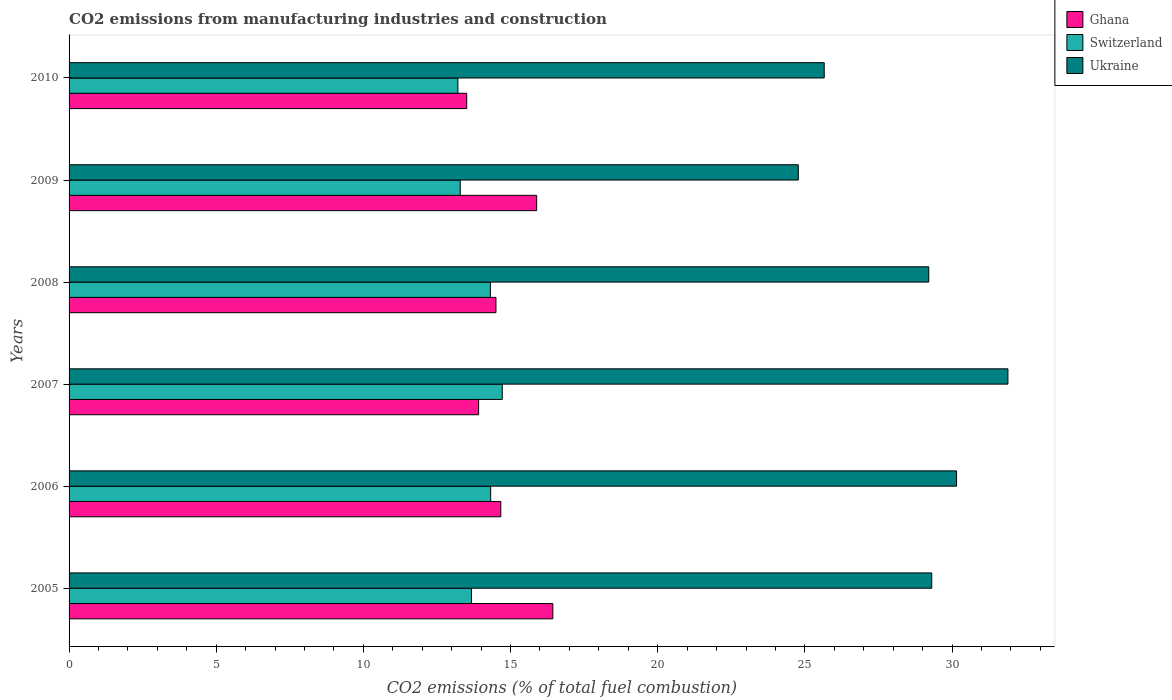How many different coloured bars are there?
Give a very brief answer. 3. How many groups of bars are there?
Provide a short and direct response. 6. Are the number of bars per tick equal to the number of legend labels?
Provide a short and direct response. Yes. Are the number of bars on each tick of the Y-axis equal?
Provide a succinct answer. Yes. What is the amount of CO2 emitted in Ghana in 2007?
Ensure brevity in your answer.  13.92. Across all years, what is the maximum amount of CO2 emitted in Ghana?
Provide a short and direct response. 16.44. Across all years, what is the minimum amount of CO2 emitted in Switzerland?
Offer a terse response. 13.21. In which year was the amount of CO2 emitted in Ukraine maximum?
Your answer should be very brief. 2007. What is the total amount of CO2 emitted in Switzerland in the graph?
Your answer should be compact. 83.53. What is the difference between the amount of CO2 emitted in Switzerland in 2006 and that in 2008?
Ensure brevity in your answer.  0.01. What is the difference between the amount of CO2 emitted in Ghana in 2006 and the amount of CO2 emitted in Ukraine in 2005?
Offer a very short reply. -14.64. What is the average amount of CO2 emitted in Ukraine per year?
Your answer should be compact. 28.5. In the year 2007, what is the difference between the amount of CO2 emitted in Ukraine and amount of CO2 emitted in Ghana?
Give a very brief answer. 17.98. In how many years, is the amount of CO2 emitted in Ghana greater than 20 %?
Your answer should be very brief. 0. What is the ratio of the amount of CO2 emitted in Ghana in 2005 to that in 2010?
Offer a terse response. 1.22. Is the amount of CO2 emitted in Ghana in 2005 less than that in 2008?
Offer a terse response. No. What is the difference between the highest and the second highest amount of CO2 emitted in Switzerland?
Provide a succinct answer. 0.39. What is the difference between the highest and the lowest amount of CO2 emitted in Switzerland?
Provide a short and direct response. 1.51. In how many years, is the amount of CO2 emitted in Ghana greater than the average amount of CO2 emitted in Ghana taken over all years?
Provide a succinct answer. 2. What does the 2nd bar from the top in 2008 represents?
Ensure brevity in your answer.  Switzerland. What does the 3rd bar from the bottom in 2007 represents?
Ensure brevity in your answer.  Ukraine. How many years are there in the graph?
Ensure brevity in your answer.  6. What is the title of the graph?
Give a very brief answer. CO2 emissions from manufacturing industries and construction. What is the label or title of the X-axis?
Keep it short and to the point. CO2 emissions (% of total fuel combustion). What is the CO2 emissions (% of total fuel combustion) of Ghana in 2005?
Provide a short and direct response. 16.44. What is the CO2 emissions (% of total fuel combustion) in Switzerland in 2005?
Offer a very short reply. 13.67. What is the CO2 emissions (% of total fuel combustion) of Ukraine in 2005?
Your answer should be very brief. 29.31. What is the CO2 emissions (% of total fuel combustion) in Ghana in 2006?
Give a very brief answer. 14.67. What is the CO2 emissions (% of total fuel combustion) of Switzerland in 2006?
Offer a terse response. 14.32. What is the CO2 emissions (% of total fuel combustion) of Ukraine in 2006?
Your answer should be very brief. 30.15. What is the CO2 emissions (% of total fuel combustion) of Ghana in 2007?
Your answer should be very brief. 13.92. What is the CO2 emissions (% of total fuel combustion) of Switzerland in 2007?
Provide a short and direct response. 14.72. What is the CO2 emissions (% of total fuel combustion) of Ukraine in 2007?
Your answer should be compact. 31.9. What is the CO2 emissions (% of total fuel combustion) in Ghana in 2008?
Give a very brief answer. 14.5. What is the CO2 emissions (% of total fuel combustion) in Switzerland in 2008?
Your answer should be compact. 14.32. What is the CO2 emissions (% of total fuel combustion) in Ukraine in 2008?
Make the answer very short. 29.21. What is the CO2 emissions (% of total fuel combustion) in Ghana in 2009?
Provide a succinct answer. 15.89. What is the CO2 emissions (% of total fuel combustion) of Switzerland in 2009?
Keep it short and to the point. 13.29. What is the CO2 emissions (% of total fuel combustion) of Ukraine in 2009?
Make the answer very short. 24.78. What is the CO2 emissions (% of total fuel combustion) in Ghana in 2010?
Ensure brevity in your answer.  13.51. What is the CO2 emissions (% of total fuel combustion) of Switzerland in 2010?
Keep it short and to the point. 13.21. What is the CO2 emissions (% of total fuel combustion) of Ukraine in 2010?
Give a very brief answer. 25.66. Across all years, what is the maximum CO2 emissions (% of total fuel combustion) in Ghana?
Make the answer very short. 16.44. Across all years, what is the maximum CO2 emissions (% of total fuel combustion) of Switzerland?
Keep it short and to the point. 14.72. Across all years, what is the maximum CO2 emissions (% of total fuel combustion) in Ukraine?
Keep it short and to the point. 31.9. Across all years, what is the minimum CO2 emissions (% of total fuel combustion) of Ghana?
Keep it short and to the point. 13.51. Across all years, what is the minimum CO2 emissions (% of total fuel combustion) of Switzerland?
Give a very brief answer. 13.21. Across all years, what is the minimum CO2 emissions (% of total fuel combustion) of Ukraine?
Ensure brevity in your answer.  24.78. What is the total CO2 emissions (% of total fuel combustion) of Ghana in the graph?
Your answer should be compact. 88.92. What is the total CO2 emissions (% of total fuel combustion) in Switzerland in the graph?
Give a very brief answer. 83.53. What is the total CO2 emissions (% of total fuel combustion) in Ukraine in the graph?
Your response must be concise. 171.01. What is the difference between the CO2 emissions (% of total fuel combustion) in Ghana in 2005 and that in 2006?
Make the answer very short. 1.77. What is the difference between the CO2 emissions (% of total fuel combustion) in Switzerland in 2005 and that in 2006?
Keep it short and to the point. -0.65. What is the difference between the CO2 emissions (% of total fuel combustion) in Ukraine in 2005 and that in 2006?
Your response must be concise. -0.84. What is the difference between the CO2 emissions (% of total fuel combustion) in Ghana in 2005 and that in 2007?
Your answer should be compact. 2.52. What is the difference between the CO2 emissions (% of total fuel combustion) of Switzerland in 2005 and that in 2007?
Provide a succinct answer. -1.05. What is the difference between the CO2 emissions (% of total fuel combustion) in Ukraine in 2005 and that in 2007?
Your response must be concise. -2.59. What is the difference between the CO2 emissions (% of total fuel combustion) in Ghana in 2005 and that in 2008?
Offer a very short reply. 1.93. What is the difference between the CO2 emissions (% of total fuel combustion) in Switzerland in 2005 and that in 2008?
Make the answer very short. -0.64. What is the difference between the CO2 emissions (% of total fuel combustion) of Ukraine in 2005 and that in 2008?
Offer a very short reply. 0.1. What is the difference between the CO2 emissions (% of total fuel combustion) in Ghana in 2005 and that in 2009?
Keep it short and to the point. 0.55. What is the difference between the CO2 emissions (% of total fuel combustion) in Switzerland in 2005 and that in 2009?
Offer a terse response. 0.38. What is the difference between the CO2 emissions (% of total fuel combustion) in Ukraine in 2005 and that in 2009?
Your answer should be very brief. 4.53. What is the difference between the CO2 emissions (% of total fuel combustion) in Ghana in 2005 and that in 2010?
Ensure brevity in your answer.  2.93. What is the difference between the CO2 emissions (% of total fuel combustion) of Switzerland in 2005 and that in 2010?
Provide a succinct answer. 0.46. What is the difference between the CO2 emissions (% of total fuel combustion) of Ukraine in 2005 and that in 2010?
Your response must be concise. 3.65. What is the difference between the CO2 emissions (% of total fuel combustion) in Ghana in 2006 and that in 2007?
Keep it short and to the point. 0.75. What is the difference between the CO2 emissions (% of total fuel combustion) of Switzerland in 2006 and that in 2007?
Ensure brevity in your answer.  -0.39. What is the difference between the CO2 emissions (% of total fuel combustion) of Ukraine in 2006 and that in 2007?
Provide a succinct answer. -1.75. What is the difference between the CO2 emissions (% of total fuel combustion) of Ghana in 2006 and that in 2008?
Your answer should be compact. 0.16. What is the difference between the CO2 emissions (% of total fuel combustion) of Switzerland in 2006 and that in 2008?
Your answer should be very brief. 0.01. What is the difference between the CO2 emissions (% of total fuel combustion) in Ukraine in 2006 and that in 2008?
Your answer should be compact. 0.94. What is the difference between the CO2 emissions (% of total fuel combustion) of Ghana in 2006 and that in 2009?
Make the answer very short. -1.22. What is the difference between the CO2 emissions (% of total fuel combustion) of Switzerland in 2006 and that in 2009?
Offer a terse response. 1.03. What is the difference between the CO2 emissions (% of total fuel combustion) of Ukraine in 2006 and that in 2009?
Keep it short and to the point. 5.38. What is the difference between the CO2 emissions (% of total fuel combustion) of Ghana in 2006 and that in 2010?
Make the answer very short. 1.16. What is the difference between the CO2 emissions (% of total fuel combustion) in Switzerland in 2006 and that in 2010?
Your answer should be very brief. 1.11. What is the difference between the CO2 emissions (% of total fuel combustion) in Ukraine in 2006 and that in 2010?
Give a very brief answer. 4.5. What is the difference between the CO2 emissions (% of total fuel combustion) of Ghana in 2007 and that in 2008?
Your answer should be very brief. -0.59. What is the difference between the CO2 emissions (% of total fuel combustion) in Switzerland in 2007 and that in 2008?
Offer a very short reply. 0.4. What is the difference between the CO2 emissions (% of total fuel combustion) of Ukraine in 2007 and that in 2008?
Provide a succinct answer. 2.69. What is the difference between the CO2 emissions (% of total fuel combustion) in Ghana in 2007 and that in 2009?
Offer a terse response. -1.97. What is the difference between the CO2 emissions (% of total fuel combustion) in Switzerland in 2007 and that in 2009?
Keep it short and to the point. 1.43. What is the difference between the CO2 emissions (% of total fuel combustion) in Ukraine in 2007 and that in 2009?
Provide a succinct answer. 7.12. What is the difference between the CO2 emissions (% of total fuel combustion) of Ghana in 2007 and that in 2010?
Offer a terse response. 0.4. What is the difference between the CO2 emissions (% of total fuel combustion) of Switzerland in 2007 and that in 2010?
Your response must be concise. 1.51. What is the difference between the CO2 emissions (% of total fuel combustion) in Ukraine in 2007 and that in 2010?
Offer a terse response. 6.24. What is the difference between the CO2 emissions (% of total fuel combustion) in Ghana in 2008 and that in 2009?
Offer a terse response. -1.38. What is the difference between the CO2 emissions (% of total fuel combustion) of Switzerland in 2008 and that in 2009?
Your answer should be compact. 1.02. What is the difference between the CO2 emissions (% of total fuel combustion) in Ukraine in 2008 and that in 2009?
Offer a very short reply. 4.43. What is the difference between the CO2 emissions (% of total fuel combustion) in Switzerland in 2008 and that in 2010?
Offer a terse response. 1.1. What is the difference between the CO2 emissions (% of total fuel combustion) of Ukraine in 2008 and that in 2010?
Ensure brevity in your answer.  3.55. What is the difference between the CO2 emissions (% of total fuel combustion) in Ghana in 2009 and that in 2010?
Your answer should be very brief. 2.38. What is the difference between the CO2 emissions (% of total fuel combustion) of Switzerland in 2009 and that in 2010?
Offer a terse response. 0.08. What is the difference between the CO2 emissions (% of total fuel combustion) of Ukraine in 2009 and that in 2010?
Your answer should be compact. -0.88. What is the difference between the CO2 emissions (% of total fuel combustion) of Ghana in 2005 and the CO2 emissions (% of total fuel combustion) of Switzerland in 2006?
Keep it short and to the point. 2.11. What is the difference between the CO2 emissions (% of total fuel combustion) of Ghana in 2005 and the CO2 emissions (% of total fuel combustion) of Ukraine in 2006?
Your response must be concise. -13.72. What is the difference between the CO2 emissions (% of total fuel combustion) in Switzerland in 2005 and the CO2 emissions (% of total fuel combustion) in Ukraine in 2006?
Make the answer very short. -16.48. What is the difference between the CO2 emissions (% of total fuel combustion) in Ghana in 2005 and the CO2 emissions (% of total fuel combustion) in Switzerland in 2007?
Your response must be concise. 1.72. What is the difference between the CO2 emissions (% of total fuel combustion) of Ghana in 2005 and the CO2 emissions (% of total fuel combustion) of Ukraine in 2007?
Your response must be concise. -15.46. What is the difference between the CO2 emissions (% of total fuel combustion) in Switzerland in 2005 and the CO2 emissions (% of total fuel combustion) in Ukraine in 2007?
Give a very brief answer. -18.23. What is the difference between the CO2 emissions (% of total fuel combustion) of Ghana in 2005 and the CO2 emissions (% of total fuel combustion) of Switzerland in 2008?
Your answer should be very brief. 2.12. What is the difference between the CO2 emissions (% of total fuel combustion) in Ghana in 2005 and the CO2 emissions (% of total fuel combustion) in Ukraine in 2008?
Your response must be concise. -12.77. What is the difference between the CO2 emissions (% of total fuel combustion) in Switzerland in 2005 and the CO2 emissions (% of total fuel combustion) in Ukraine in 2008?
Your response must be concise. -15.54. What is the difference between the CO2 emissions (% of total fuel combustion) in Ghana in 2005 and the CO2 emissions (% of total fuel combustion) in Switzerland in 2009?
Keep it short and to the point. 3.15. What is the difference between the CO2 emissions (% of total fuel combustion) of Ghana in 2005 and the CO2 emissions (% of total fuel combustion) of Ukraine in 2009?
Make the answer very short. -8.34. What is the difference between the CO2 emissions (% of total fuel combustion) in Switzerland in 2005 and the CO2 emissions (% of total fuel combustion) in Ukraine in 2009?
Ensure brevity in your answer.  -11.11. What is the difference between the CO2 emissions (% of total fuel combustion) of Ghana in 2005 and the CO2 emissions (% of total fuel combustion) of Switzerland in 2010?
Provide a short and direct response. 3.23. What is the difference between the CO2 emissions (% of total fuel combustion) in Ghana in 2005 and the CO2 emissions (% of total fuel combustion) in Ukraine in 2010?
Your answer should be very brief. -9.22. What is the difference between the CO2 emissions (% of total fuel combustion) in Switzerland in 2005 and the CO2 emissions (% of total fuel combustion) in Ukraine in 2010?
Your answer should be very brief. -11.99. What is the difference between the CO2 emissions (% of total fuel combustion) in Ghana in 2006 and the CO2 emissions (% of total fuel combustion) in Ukraine in 2007?
Your answer should be compact. -17.23. What is the difference between the CO2 emissions (% of total fuel combustion) of Switzerland in 2006 and the CO2 emissions (% of total fuel combustion) of Ukraine in 2007?
Provide a short and direct response. -17.57. What is the difference between the CO2 emissions (% of total fuel combustion) in Ghana in 2006 and the CO2 emissions (% of total fuel combustion) in Switzerland in 2008?
Ensure brevity in your answer.  0.35. What is the difference between the CO2 emissions (% of total fuel combustion) in Ghana in 2006 and the CO2 emissions (% of total fuel combustion) in Ukraine in 2008?
Provide a short and direct response. -14.54. What is the difference between the CO2 emissions (% of total fuel combustion) of Switzerland in 2006 and the CO2 emissions (% of total fuel combustion) of Ukraine in 2008?
Your answer should be very brief. -14.88. What is the difference between the CO2 emissions (% of total fuel combustion) in Ghana in 2006 and the CO2 emissions (% of total fuel combustion) in Switzerland in 2009?
Your answer should be compact. 1.38. What is the difference between the CO2 emissions (% of total fuel combustion) in Ghana in 2006 and the CO2 emissions (% of total fuel combustion) in Ukraine in 2009?
Ensure brevity in your answer.  -10.11. What is the difference between the CO2 emissions (% of total fuel combustion) in Switzerland in 2006 and the CO2 emissions (% of total fuel combustion) in Ukraine in 2009?
Offer a very short reply. -10.45. What is the difference between the CO2 emissions (% of total fuel combustion) of Ghana in 2006 and the CO2 emissions (% of total fuel combustion) of Switzerland in 2010?
Provide a succinct answer. 1.46. What is the difference between the CO2 emissions (% of total fuel combustion) in Ghana in 2006 and the CO2 emissions (% of total fuel combustion) in Ukraine in 2010?
Offer a very short reply. -10.99. What is the difference between the CO2 emissions (% of total fuel combustion) in Switzerland in 2006 and the CO2 emissions (% of total fuel combustion) in Ukraine in 2010?
Offer a terse response. -11.33. What is the difference between the CO2 emissions (% of total fuel combustion) of Ghana in 2007 and the CO2 emissions (% of total fuel combustion) of Ukraine in 2008?
Provide a short and direct response. -15.29. What is the difference between the CO2 emissions (% of total fuel combustion) in Switzerland in 2007 and the CO2 emissions (% of total fuel combustion) in Ukraine in 2008?
Ensure brevity in your answer.  -14.49. What is the difference between the CO2 emissions (% of total fuel combustion) in Ghana in 2007 and the CO2 emissions (% of total fuel combustion) in Switzerland in 2009?
Keep it short and to the point. 0.62. What is the difference between the CO2 emissions (% of total fuel combustion) of Ghana in 2007 and the CO2 emissions (% of total fuel combustion) of Ukraine in 2009?
Give a very brief answer. -10.86. What is the difference between the CO2 emissions (% of total fuel combustion) of Switzerland in 2007 and the CO2 emissions (% of total fuel combustion) of Ukraine in 2009?
Your response must be concise. -10.06. What is the difference between the CO2 emissions (% of total fuel combustion) in Ghana in 2007 and the CO2 emissions (% of total fuel combustion) in Switzerland in 2010?
Your answer should be compact. 0.7. What is the difference between the CO2 emissions (% of total fuel combustion) of Ghana in 2007 and the CO2 emissions (% of total fuel combustion) of Ukraine in 2010?
Offer a terse response. -11.74. What is the difference between the CO2 emissions (% of total fuel combustion) of Switzerland in 2007 and the CO2 emissions (% of total fuel combustion) of Ukraine in 2010?
Keep it short and to the point. -10.94. What is the difference between the CO2 emissions (% of total fuel combustion) in Ghana in 2008 and the CO2 emissions (% of total fuel combustion) in Switzerland in 2009?
Make the answer very short. 1.21. What is the difference between the CO2 emissions (% of total fuel combustion) of Ghana in 2008 and the CO2 emissions (% of total fuel combustion) of Ukraine in 2009?
Give a very brief answer. -10.27. What is the difference between the CO2 emissions (% of total fuel combustion) of Switzerland in 2008 and the CO2 emissions (% of total fuel combustion) of Ukraine in 2009?
Provide a short and direct response. -10.46. What is the difference between the CO2 emissions (% of total fuel combustion) in Ghana in 2008 and the CO2 emissions (% of total fuel combustion) in Switzerland in 2010?
Make the answer very short. 1.29. What is the difference between the CO2 emissions (% of total fuel combustion) in Ghana in 2008 and the CO2 emissions (% of total fuel combustion) in Ukraine in 2010?
Give a very brief answer. -11.15. What is the difference between the CO2 emissions (% of total fuel combustion) in Switzerland in 2008 and the CO2 emissions (% of total fuel combustion) in Ukraine in 2010?
Your answer should be very brief. -11.34. What is the difference between the CO2 emissions (% of total fuel combustion) of Ghana in 2009 and the CO2 emissions (% of total fuel combustion) of Switzerland in 2010?
Provide a succinct answer. 2.68. What is the difference between the CO2 emissions (% of total fuel combustion) in Ghana in 2009 and the CO2 emissions (% of total fuel combustion) in Ukraine in 2010?
Your answer should be compact. -9.77. What is the difference between the CO2 emissions (% of total fuel combustion) in Switzerland in 2009 and the CO2 emissions (% of total fuel combustion) in Ukraine in 2010?
Provide a short and direct response. -12.37. What is the average CO2 emissions (% of total fuel combustion) in Ghana per year?
Your response must be concise. 14.82. What is the average CO2 emissions (% of total fuel combustion) of Switzerland per year?
Give a very brief answer. 13.92. What is the average CO2 emissions (% of total fuel combustion) in Ukraine per year?
Offer a very short reply. 28.5. In the year 2005, what is the difference between the CO2 emissions (% of total fuel combustion) in Ghana and CO2 emissions (% of total fuel combustion) in Switzerland?
Keep it short and to the point. 2.77. In the year 2005, what is the difference between the CO2 emissions (% of total fuel combustion) of Ghana and CO2 emissions (% of total fuel combustion) of Ukraine?
Keep it short and to the point. -12.87. In the year 2005, what is the difference between the CO2 emissions (% of total fuel combustion) in Switzerland and CO2 emissions (% of total fuel combustion) in Ukraine?
Make the answer very short. -15.64. In the year 2006, what is the difference between the CO2 emissions (% of total fuel combustion) in Ghana and CO2 emissions (% of total fuel combustion) in Switzerland?
Keep it short and to the point. 0.34. In the year 2006, what is the difference between the CO2 emissions (% of total fuel combustion) of Ghana and CO2 emissions (% of total fuel combustion) of Ukraine?
Provide a succinct answer. -15.48. In the year 2006, what is the difference between the CO2 emissions (% of total fuel combustion) of Switzerland and CO2 emissions (% of total fuel combustion) of Ukraine?
Ensure brevity in your answer.  -15.83. In the year 2007, what is the difference between the CO2 emissions (% of total fuel combustion) of Ghana and CO2 emissions (% of total fuel combustion) of Switzerland?
Make the answer very short. -0.8. In the year 2007, what is the difference between the CO2 emissions (% of total fuel combustion) in Ghana and CO2 emissions (% of total fuel combustion) in Ukraine?
Ensure brevity in your answer.  -17.98. In the year 2007, what is the difference between the CO2 emissions (% of total fuel combustion) in Switzerland and CO2 emissions (% of total fuel combustion) in Ukraine?
Make the answer very short. -17.18. In the year 2008, what is the difference between the CO2 emissions (% of total fuel combustion) of Ghana and CO2 emissions (% of total fuel combustion) of Switzerland?
Provide a short and direct response. 0.19. In the year 2008, what is the difference between the CO2 emissions (% of total fuel combustion) of Ghana and CO2 emissions (% of total fuel combustion) of Ukraine?
Your answer should be very brief. -14.71. In the year 2008, what is the difference between the CO2 emissions (% of total fuel combustion) in Switzerland and CO2 emissions (% of total fuel combustion) in Ukraine?
Give a very brief answer. -14.89. In the year 2009, what is the difference between the CO2 emissions (% of total fuel combustion) in Ghana and CO2 emissions (% of total fuel combustion) in Switzerland?
Your answer should be compact. 2.6. In the year 2009, what is the difference between the CO2 emissions (% of total fuel combustion) of Ghana and CO2 emissions (% of total fuel combustion) of Ukraine?
Ensure brevity in your answer.  -8.89. In the year 2009, what is the difference between the CO2 emissions (% of total fuel combustion) in Switzerland and CO2 emissions (% of total fuel combustion) in Ukraine?
Provide a short and direct response. -11.49. In the year 2010, what is the difference between the CO2 emissions (% of total fuel combustion) in Ghana and CO2 emissions (% of total fuel combustion) in Switzerland?
Offer a very short reply. 0.3. In the year 2010, what is the difference between the CO2 emissions (% of total fuel combustion) of Ghana and CO2 emissions (% of total fuel combustion) of Ukraine?
Provide a short and direct response. -12.15. In the year 2010, what is the difference between the CO2 emissions (% of total fuel combustion) of Switzerland and CO2 emissions (% of total fuel combustion) of Ukraine?
Ensure brevity in your answer.  -12.45. What is the ratio of the CO2 emissions (% of total fuel combustion) of Ghana in 2005 to that in 2006?
Ensure brevity in your answer.  1.12. What is the ratio of the CO2 emissions (% of total fuel combustion) of Switzerland in 2005 to that in 2006?
Offer a terse response. 0.95. What is the ratio of the CO2 emissions (% of total fuel combustion) of Ghana in 2005 to that in 2007?
Provide a succinct answer. 1.18. What is the ratio of the CO2 emissions (% of total fuel combustion) in Switzerland in 2005 to that in 2007?
Your response must be concise. 0.93. What is the ratio of the CO2 emissions (% of total fuel combustion) in Ukraine in 2005 to that in 2007?
Offer a very short reply. 0.92. What is the ratio of the CO2 emissions (% of total fuel combustion) of Ghana in 2005 to that in 2008?
Your response must be concise. 1.13. What is the ratio of the CO2 emissions (% of total fuel combustion) of Switzerland in 2005 to that in 2008?
Your answer should be very brief. 0.95. What is the ratio of the CO2 emissions (% of total fuel combustion) in Ghana in 2005 to that in 2009?
Ensure brevity in your answer.  1.03. What is the ratio of the CO2 emissions (% of total fuel combustion) in Switzerland in 2005 to that in 2009?
Give a very brief answer. 1.03. What is the ratio of the CO2 emissions (% of total fuel combustion) in Ukraine in 2005 to that in 2009?
Your response must be concise. 1.18. What is the ratio of the CO2 emissions (% of total fuel combustion) in Ghana in 2005 to that in 2010?
Your response must be concise. 1.22. What is the ratio of the CO2 emissions (% of total fuel combustion) of Switzerland in 2005 to that in 2010?
Ensure brevity in your answer.  1.03. What is the ratio of the CO2 emissions (% of total fuel combustion) in Ukraine in 2005 to that in 2010?
Your answer should be very brief. 1.14. What is the ratio of the CO2 emissions (% of total fuel combustion) in Ghana in 2006 to that in 2007?
Ensure brevity in your answer.  1.05. What is the ratio of the CO2 emissions (% of total fuel combustion) of Switzerland in 2006 to that in 2007?
Provide a short and direct response. 0.97. What is the ratio of the CO2 emissions (% of total fuel combustion) of Ukraine in 2006 to that in 2007?
Make the answer very short. 0.95. What is the ratio of the CO2 emissions (% of total fuel combustion) in Ghana in 2006 to that in 2008?
Give a very brief answer. 1.01. What is the ratio of the CO2 emissions (% of total fuel combustion) of Ukraine in 2006 to that in 2008?
Your response must be concise. 1.03. What is the ratio of the CO2 emissions (% of total fuel combustion) of Ghana in 2006 to that in 2009?
Your answer should be very brief. 0.92. What is the ratio of the CO2 emissions (% of total fuel combustion) of Switzerland in 2006 to that in 2009?
Provide a succinct answer. 1.08. What is the ratio of the CO2 emissions (% of total fuel combustion) of Ukraine in 2006 to that in 2009?
Your response must be concise. 1.22. What is the ratio of the CO2 emissions (% of total fuel combustion) in Ghana in 2006 to that in 2010?
Offer a terse response. 1.09. What is the ratio of the CO2 emissions (% of total fuel combustion) in Switzerland in 2006 to that in 2010?
Make the answer very short. 1.08. What is the ratio of the CO2 emissions (% of total fuel combustion) of Ukraine in 2006 to that in 2010?
Give a very brief answer. 1.18. What is the ratio of the CO2 emissions (% of total fuel combustion) in Ghana in 2007 to that in 2008?
Ensure brevity in your answer.  0.96. What is the ratio of the CO2 emissions (% of total fuel combustion) of Switzerland in 2007 to that in 2008?
Provide a succinct answer. 1.03. What is the ratio of the CO2 emissions (% of total fuel combustion) of Ukraine in 2007 to that in 2008?
Offer a terse response. 1.09. What is the ratio of the CO2 emissions (% of total fuel combustion) of Ghana in 2007 to that in 2009?
Keep it short and to the point. 0.88. What is the ratio of the CO2 emissions (% of total fuel combustion) of Switzerland in 2007 to that in 2009?
Give a very brief answer. 1.11. What is the ratio of the CO2 emissions (% of total fuel combustion) of Ukraine in 2007 to that in 2009?
Offer a very short reply. 1.29. What is the ratio of the CO2 emissions (% of total fuel combustion) in Ghana in 2007 to that in 2010?
Give a very brief answer. 1.03. What is the ratio of the CO2 emissions (% of total fuel combustion) of Switzerland in 2007 to that in 2010?
Provide a succinct answer. 1.11. What is the ratio of the CO2 emissions (% of total fuel combustion) of Ukraine in 2007 to that in 2010?
Your answer should be compact. 1.24. What is the ratio of the CO2 emissions (% of total fuel combustion) in Ghana in 2008 to that in 2009?
Offer a terse response. 0.91. What is the ratio of the CO2 emissions (% of total fuel combustion) of Switzerland in 2008 to that in 2009?
Give a very brief answer. 1.08. What is the ratio of the CO2 emissions (% of total fuel combustion) in Ukraine in 2008 to that in 2009?
Ensure brevity in your answer.  1.18. What is the ratio of the CO2 emissions (% of total fuel combustion) of Ghana in 2008 to that in 2010?
Your response must be concise. 1.07. What is the ratio of the CO2 emissions (% of total fuel combustion) in Switzerland in 2008 to that in 2010?
Ensure brevity in your answer.  1.08. What is the ratio of the CO2 emissions (% of total fuel combustion) in Ukraine in 2008 to that in 2010?
Provide a short and direct response. 1.14. What is the ratio of the CO2 emissions (% of total fuel combustion) of Ghana in 2009 to that in 2010?
Give a very brief answer. 1.18. What is the ratio of the CO2 emissions (% of total fuel combustion) of Ukraine in 2009 to that in 2010?
Make the answer very short. 0.97. What is the difference between the highest and the second highest CO2 emissions (% of total fuel combustion) in Ghana?
Your answer should be compact. 0.55. What is the difference between the highest and the second highest CO2 emissions (% of total fuel combustion) in Switzerland?
Offer a terse response. 0.39. What is the difference between the highest and the second highest CO2 emissions (% of total fuel combustion) of Ukraine?
Give a very brief answer. 1.75. What is the difference between the highest and the lowest CO2 emissions (% of total fuel combustion) in Ghana?
Give a very brief answer. 2.93. What is the difference between the highest and the lowest CO2 emissions (% of total fuel combustion) in Switzerland?
Offer a terse response. 1.51. What is the difference between the highest and the lowest CO2 emissions (% of total fuel combustion) in Ukraine?
Your answer should be very brief. 7.12. 